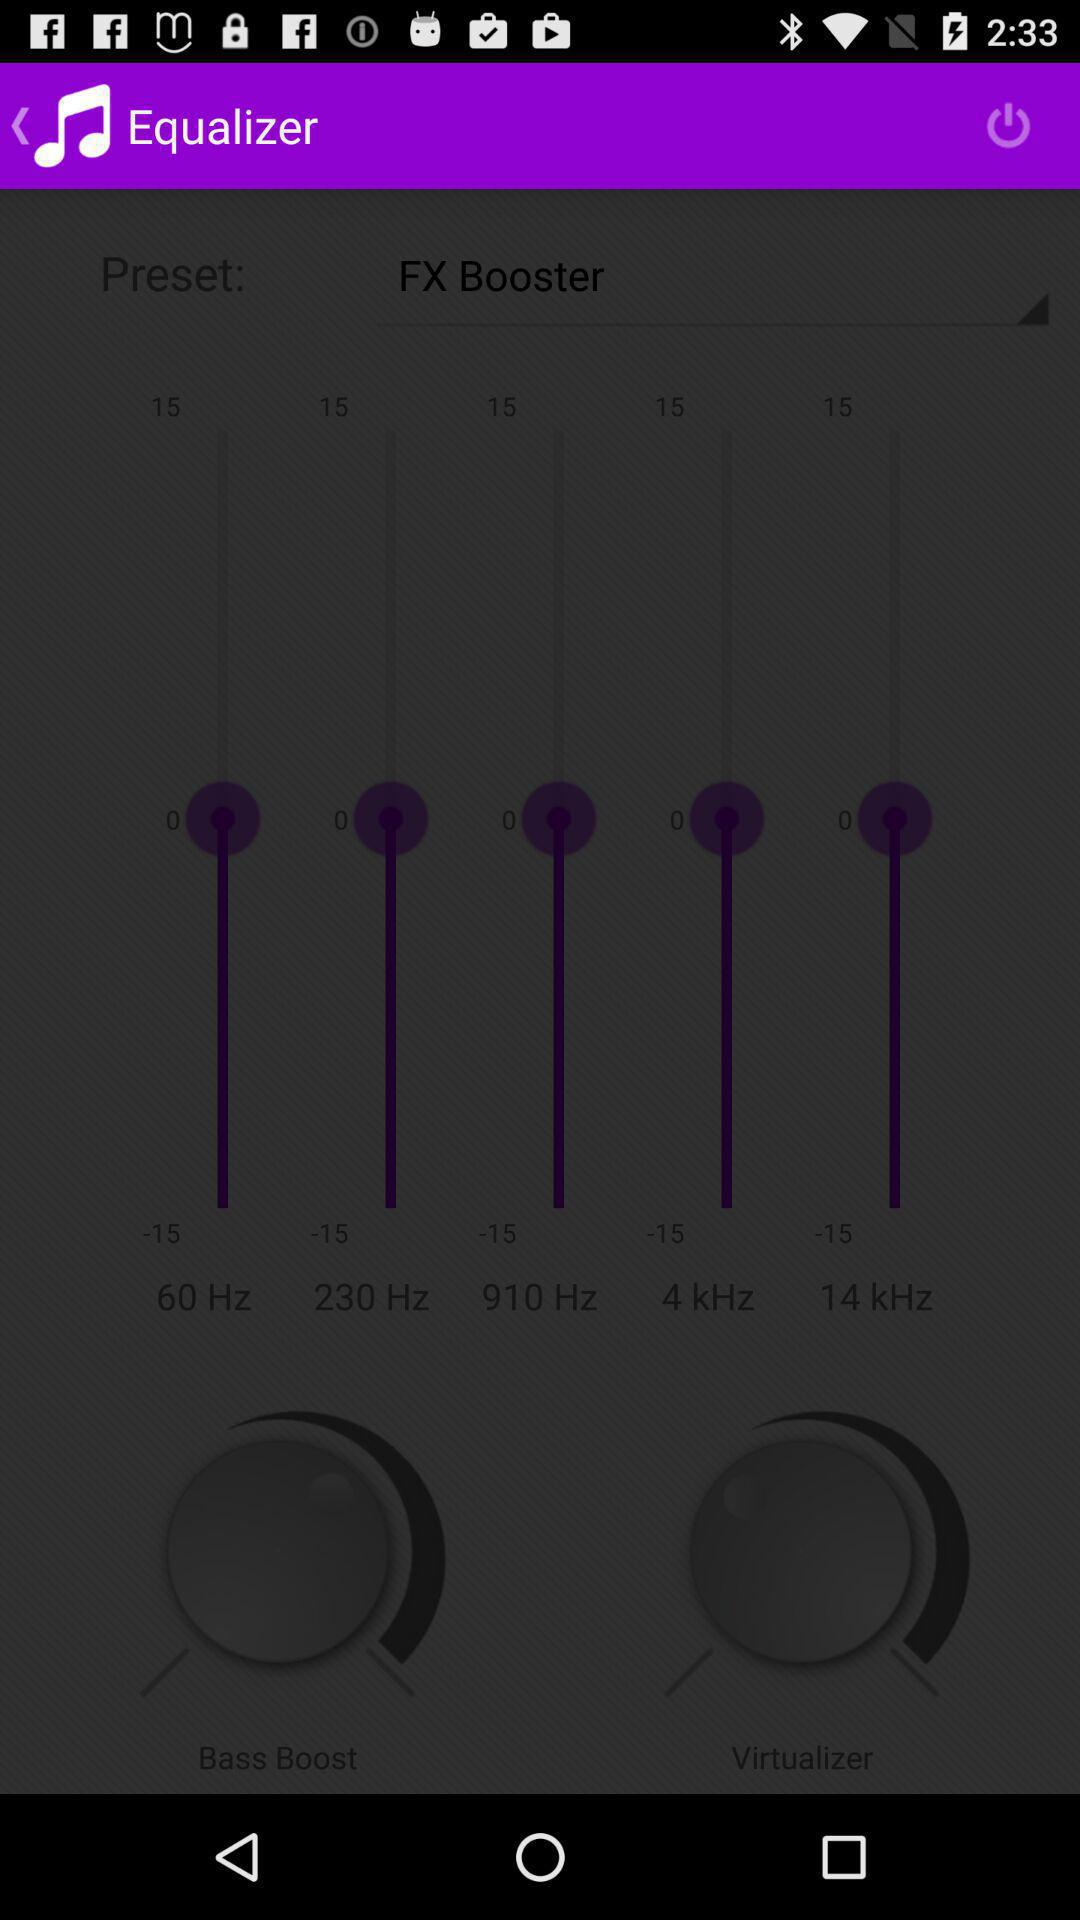How many frequency bands are there?
Answer the question using a single word or phrase. 5 